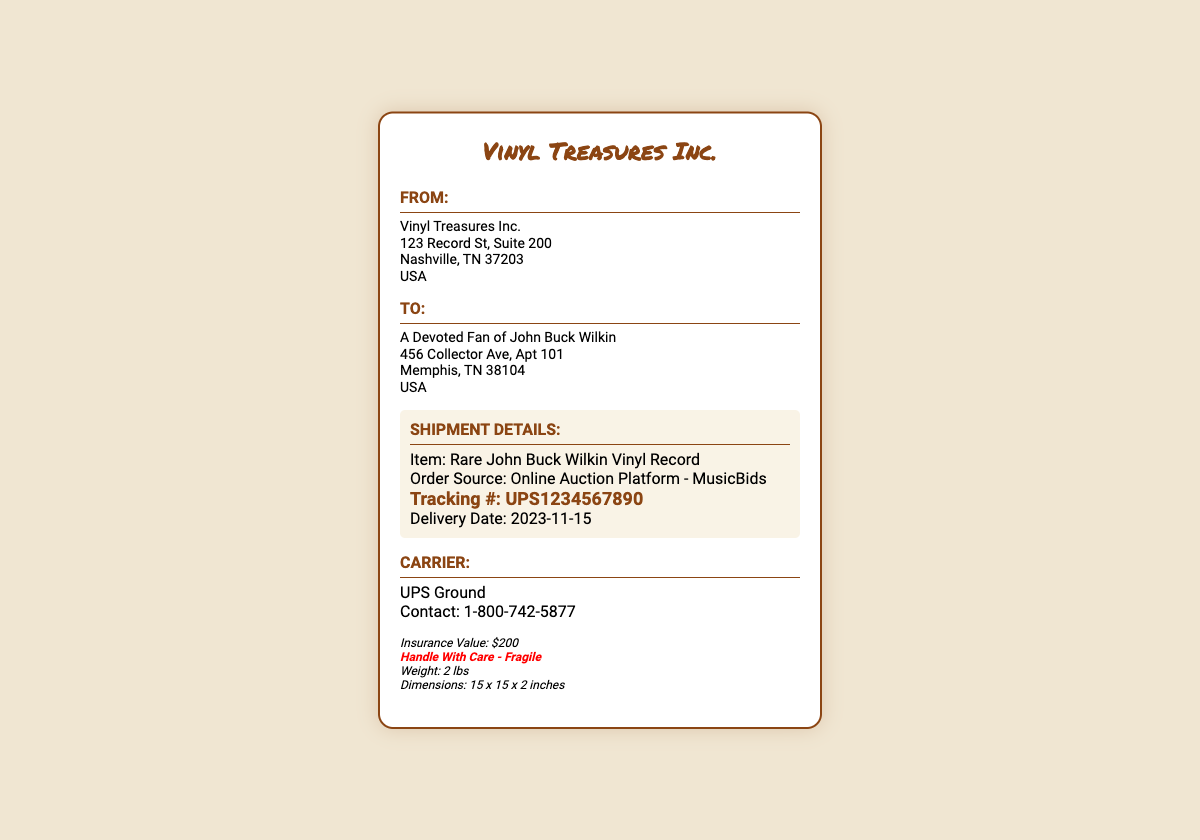What is the name of the company shipping the record? The company shipping the record is mentioned at the top of the document.
Answer: Vinyl Treasures Inc What is the tracking number for the shipment? The tracking number is found in the shipment details section.
Answer: UPS1234567890 When is the delivery date? The delivery date is specified in the shipment details.
Answer: 2023-11-15 What is the item being shipped? The item description is provided in the shipment details section.
Answer: Rare John Buck Wilkin Vinyl Record What is the weight of the package? The weight is given in the additional info section.
Answer: 2 lbs Who is the recipient of the shipping label? The recipient's name appears in the "To" section of the document.
Answer: A Devoted Fan of John Buck Wilkin What is the insurance value of the shipment? The insurance value can be found in the additional information part of the document.
Answer: $200 What handling caution is noted for the shipment? The document includes a specific note about handling the package.
Answer: Handle With Care - Fragile What are the dimensions of the package? The dimensions are listed in the additional info section.
Answer: 15 x 15 x 2 inches 